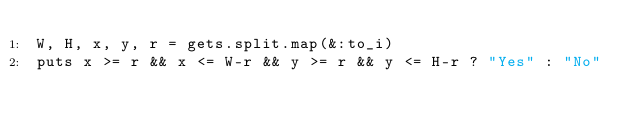Convert code to text. <code><loc_0><loc_0><loc_500><loc_500><_Ruby_>W, H, x, y, r = gets.split.map(&:to_i)
puts x >= r && x <= W-r && y >= r && y <= H-r ? "Yes" : "No"</code> 